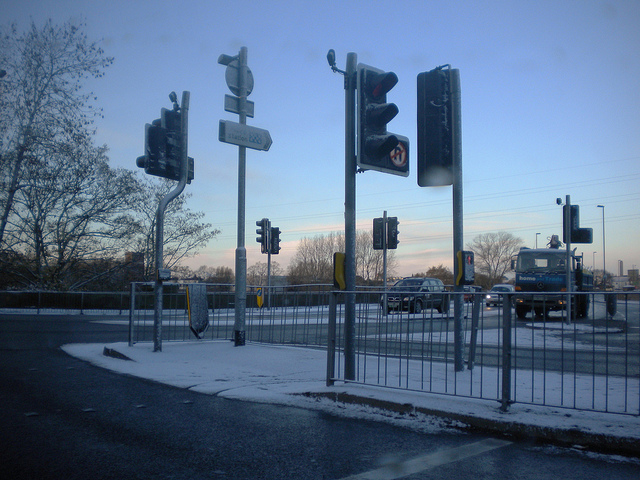<image>What color is the traffic light? I am not sure. The color of the traffic light can be red, black, gray or green. What color is the traffic light? I am not sure what color the traffic light is. It can be seen as black, red, green or gray. 